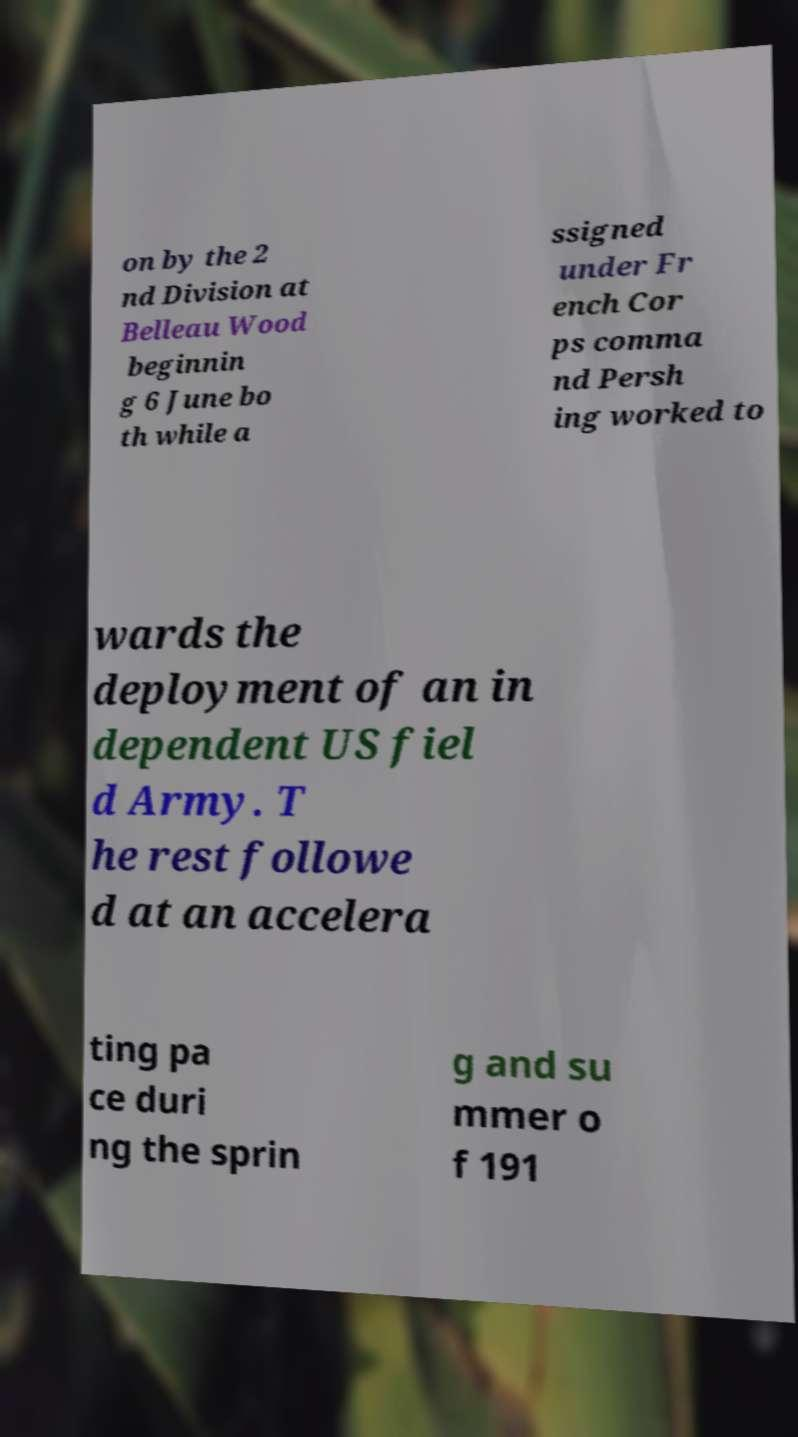Can you read and provide the text displayed in the image?This photo seems to have some interesting text. Can you extract and type it out for me? on by the 2 nd Division at Belleau Wood beginnin g 6 June bo th while a ssigned under Fr ench Cor ps comma nd Persh ing worked to wards the deployment of an in dependent US fiel d Army. T he rest followe d at an accelera ting pa ce duri ng the sprin g and su mmer o f 191 